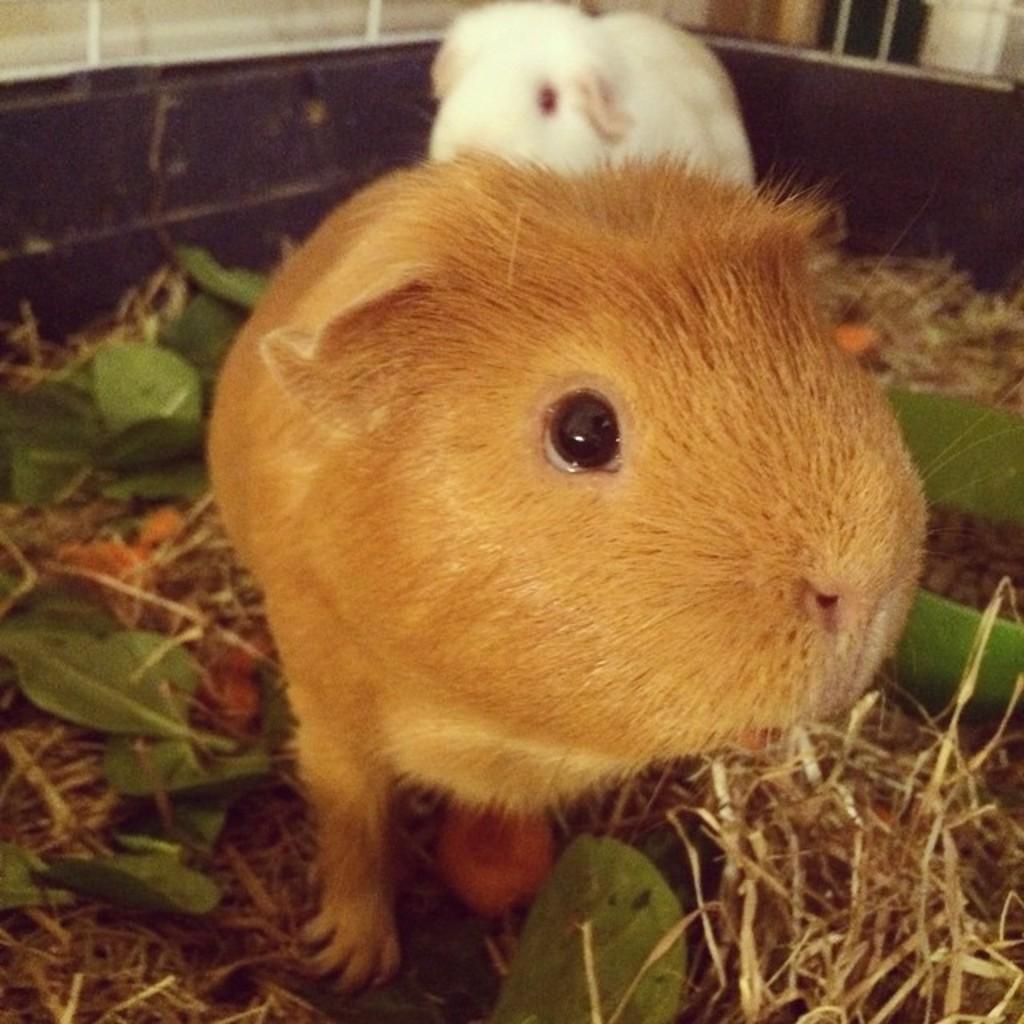How would you summarize this image in a sentence or two? In this image I can see an animal which is brown in color and another animal which is white in color on the grass and I can see few leaves which are green in color. 